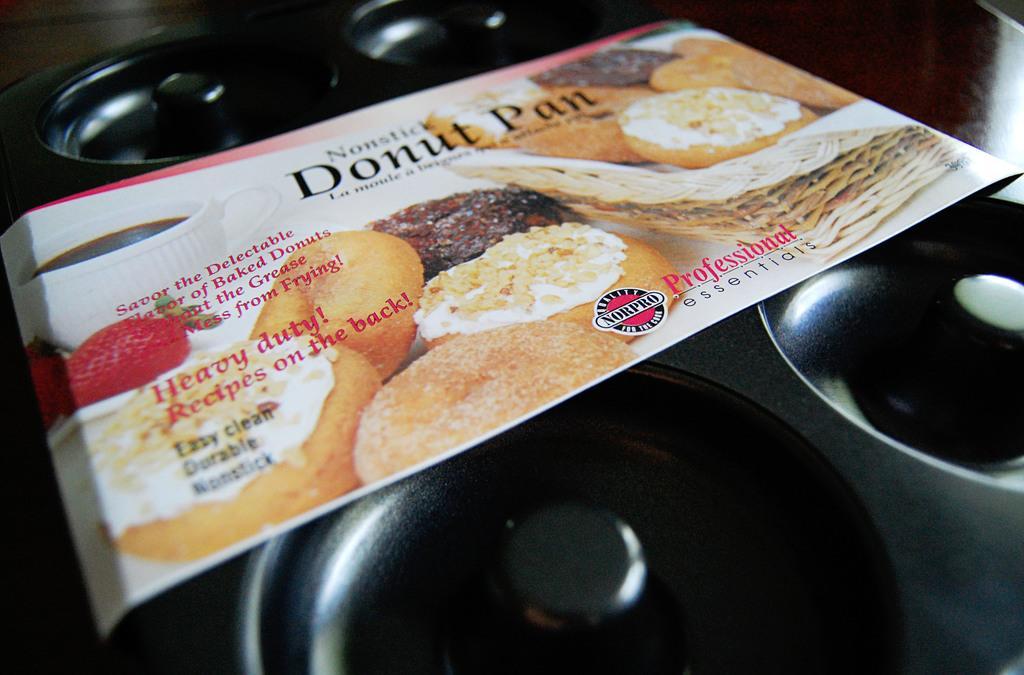Could you give a brief overview of what you see in this image? In this image I can see there is a pan on the table. And there is a label with some text attached to it. 